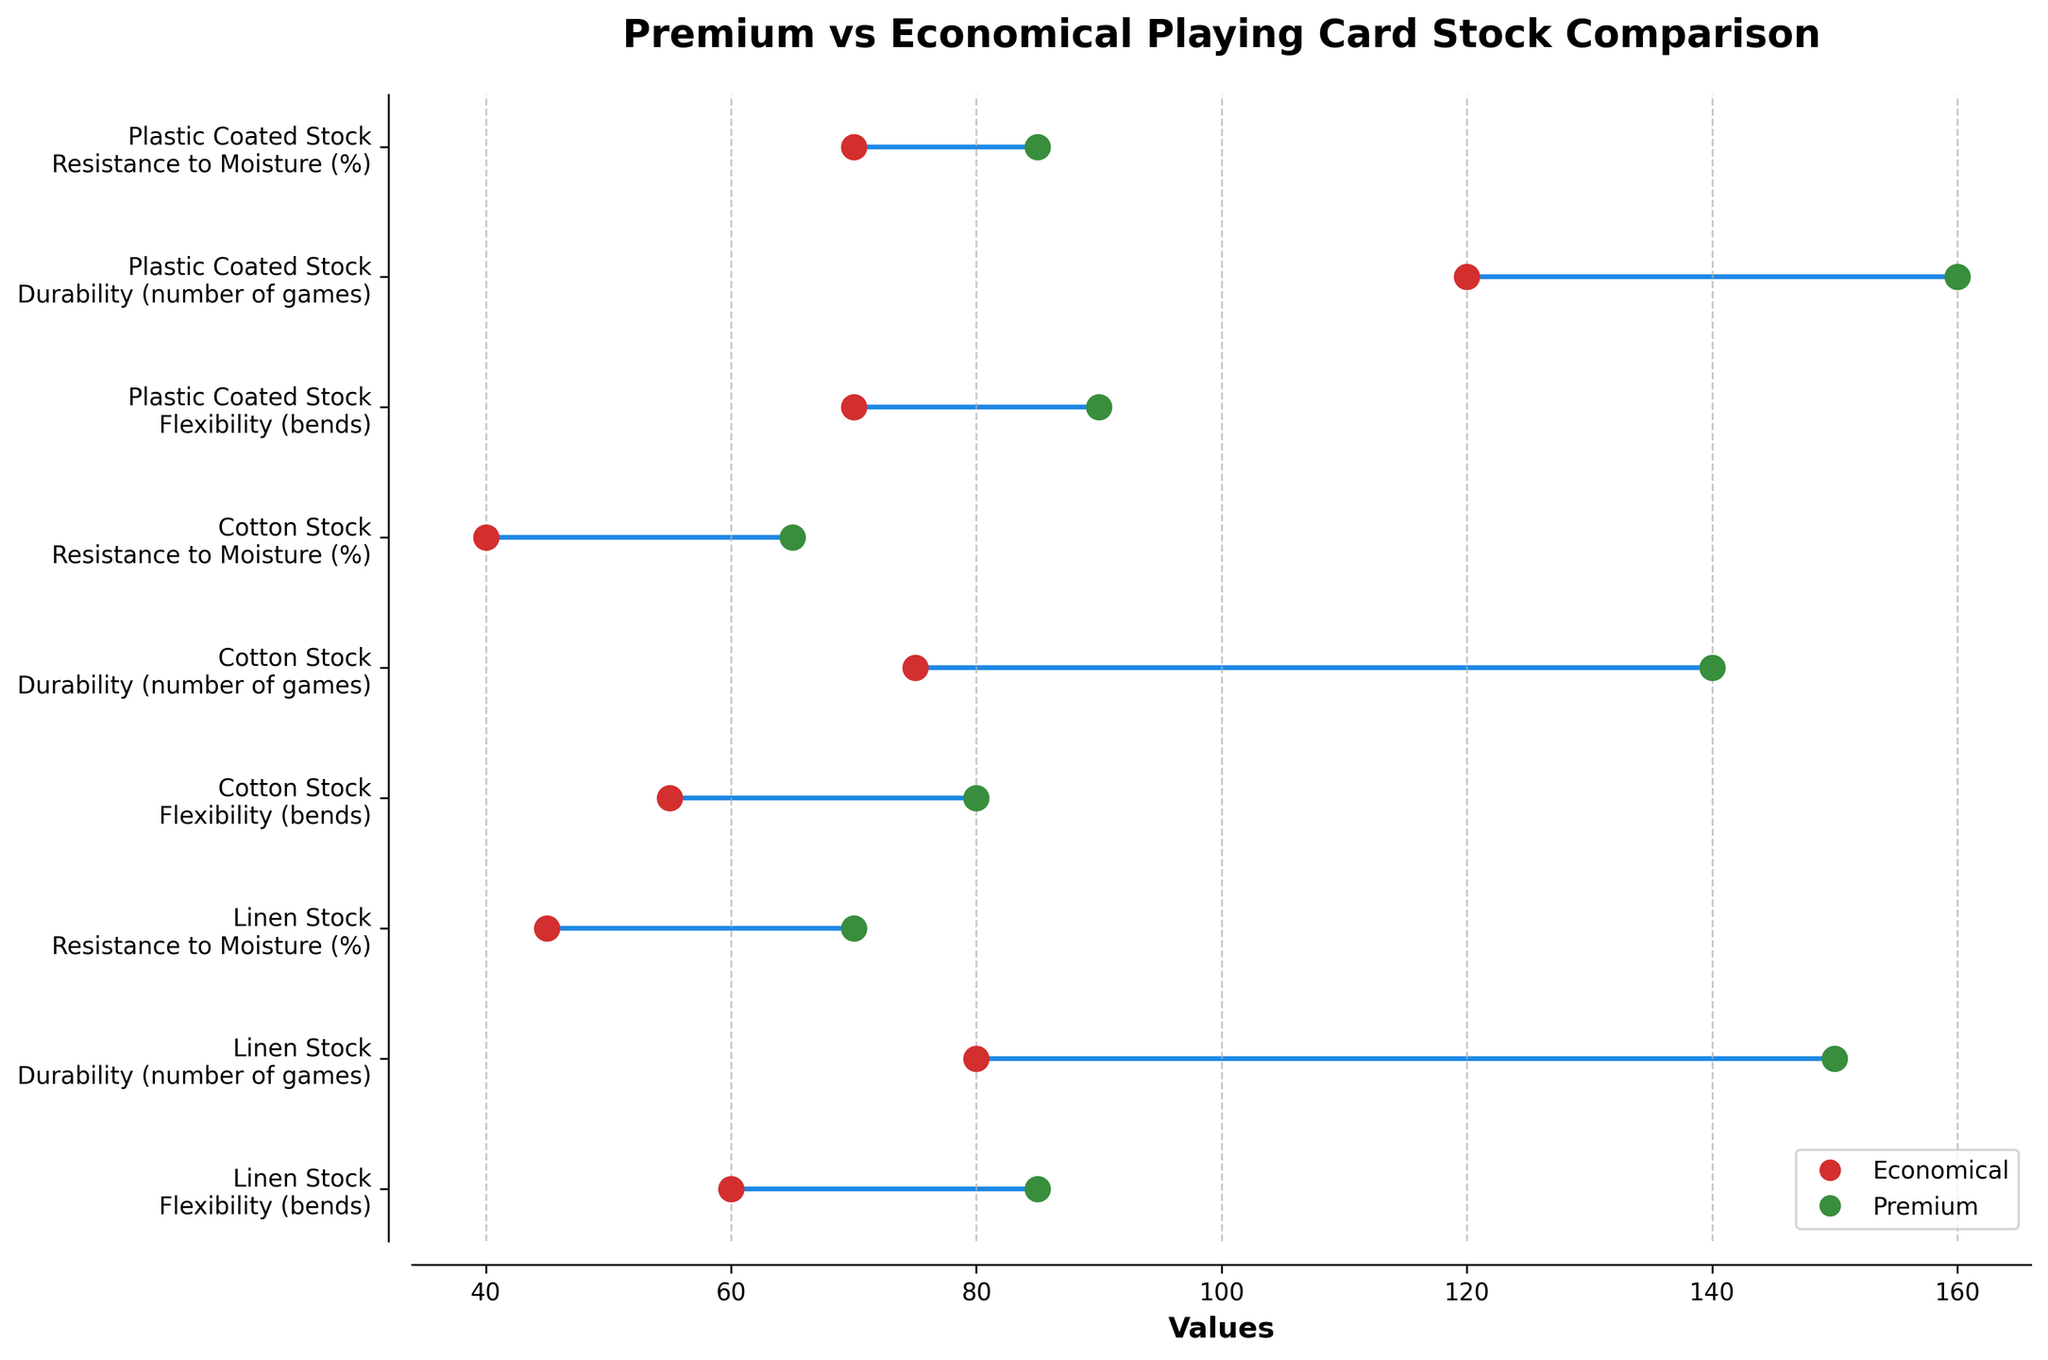What is the title of the figure? The title can be found at the top of the plot. In this case, it reads "Premium vs Economical Playing Card Stock Comparison".
Answer: Premium vs Economical Playing Card Stock Comparison How many different types of materials are compared in the figure? You can determine the number of different materials by counting the unique material labels on the y-axis. Here, they are Linen Stock, Cotton Stock, and Plastic Coated Stock.
Answer: 3 Which material has the highest flexibility (bends) in the Premium category? By looking at the flexibility data points for Premium, Plastic Coated Stock has the highest value at 90.
Answer: Plastic Coated Stock What is the difference in durability (number of games) between Premium and Economical for Cotton Stock? For Cotton Stock, the durability for Premium is 140 and for Economical is 75. The difference is calculated as 140 - 75.
Answer: 65 Which material shows the greatest resistance to moisture (%) in the Economical category? Resistance to moisture data points for Economical are at 45 for Linen Stock, 40 for Cotton Stock, and 70 for Plastic Coated Stock. Plastic Coated Stock has the highest value.
Answer: Plastic Coated Stock What is the average flexibility value for all materials in the Premium category? The flexibility values for Premium across all materials are 85, 80, and 90. The average is calculated as (85 + 80 + 90) / 3.
Answer: 85 Which attribute shows the largest overall difference between Premium and Economical across all materials? By comparing all differences: Flexibility: (85-60), (80-55), (90-70); Durability: (150-80), (140-75), (160-120); Resistance to Moisture: (70-45), (65-40), (85-70). Durability for Linen Stock shows the largest difference (150-80).
Answer: Durability (number of games) Compare the resistance to moisture (%) for Cotton Stock in Premium and Economical categories. Which one is higher? For Cotton Stock, resistance to moisture is 65% in Premium and 40% in Economical. Premium is higher.
Answer: Premium Which material shows the smallest difference in flexibility (bends) between Premium and Economical categories? The differences in flexibility for each material are: Linen Stock (85-60), Cotton Stock (80-55), and Plastic Coated Stock (90-70). The smallest difference is for Plastic Coated Stock (90-70).
Answer: Plastic Coated Stock Which category has overall higher values, Premium or Economical? By visual inspection, Premium values are consistently higher than Economical values across all attributes and materials.
Answer: Premium 